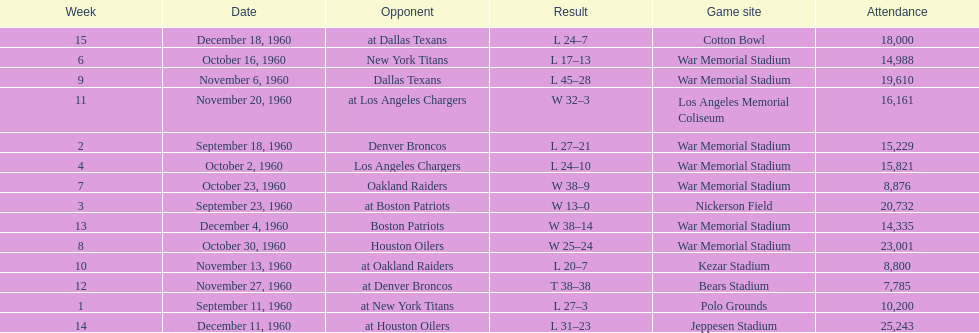Who did the bills play after the oakland raiders? Houston Oilers. 